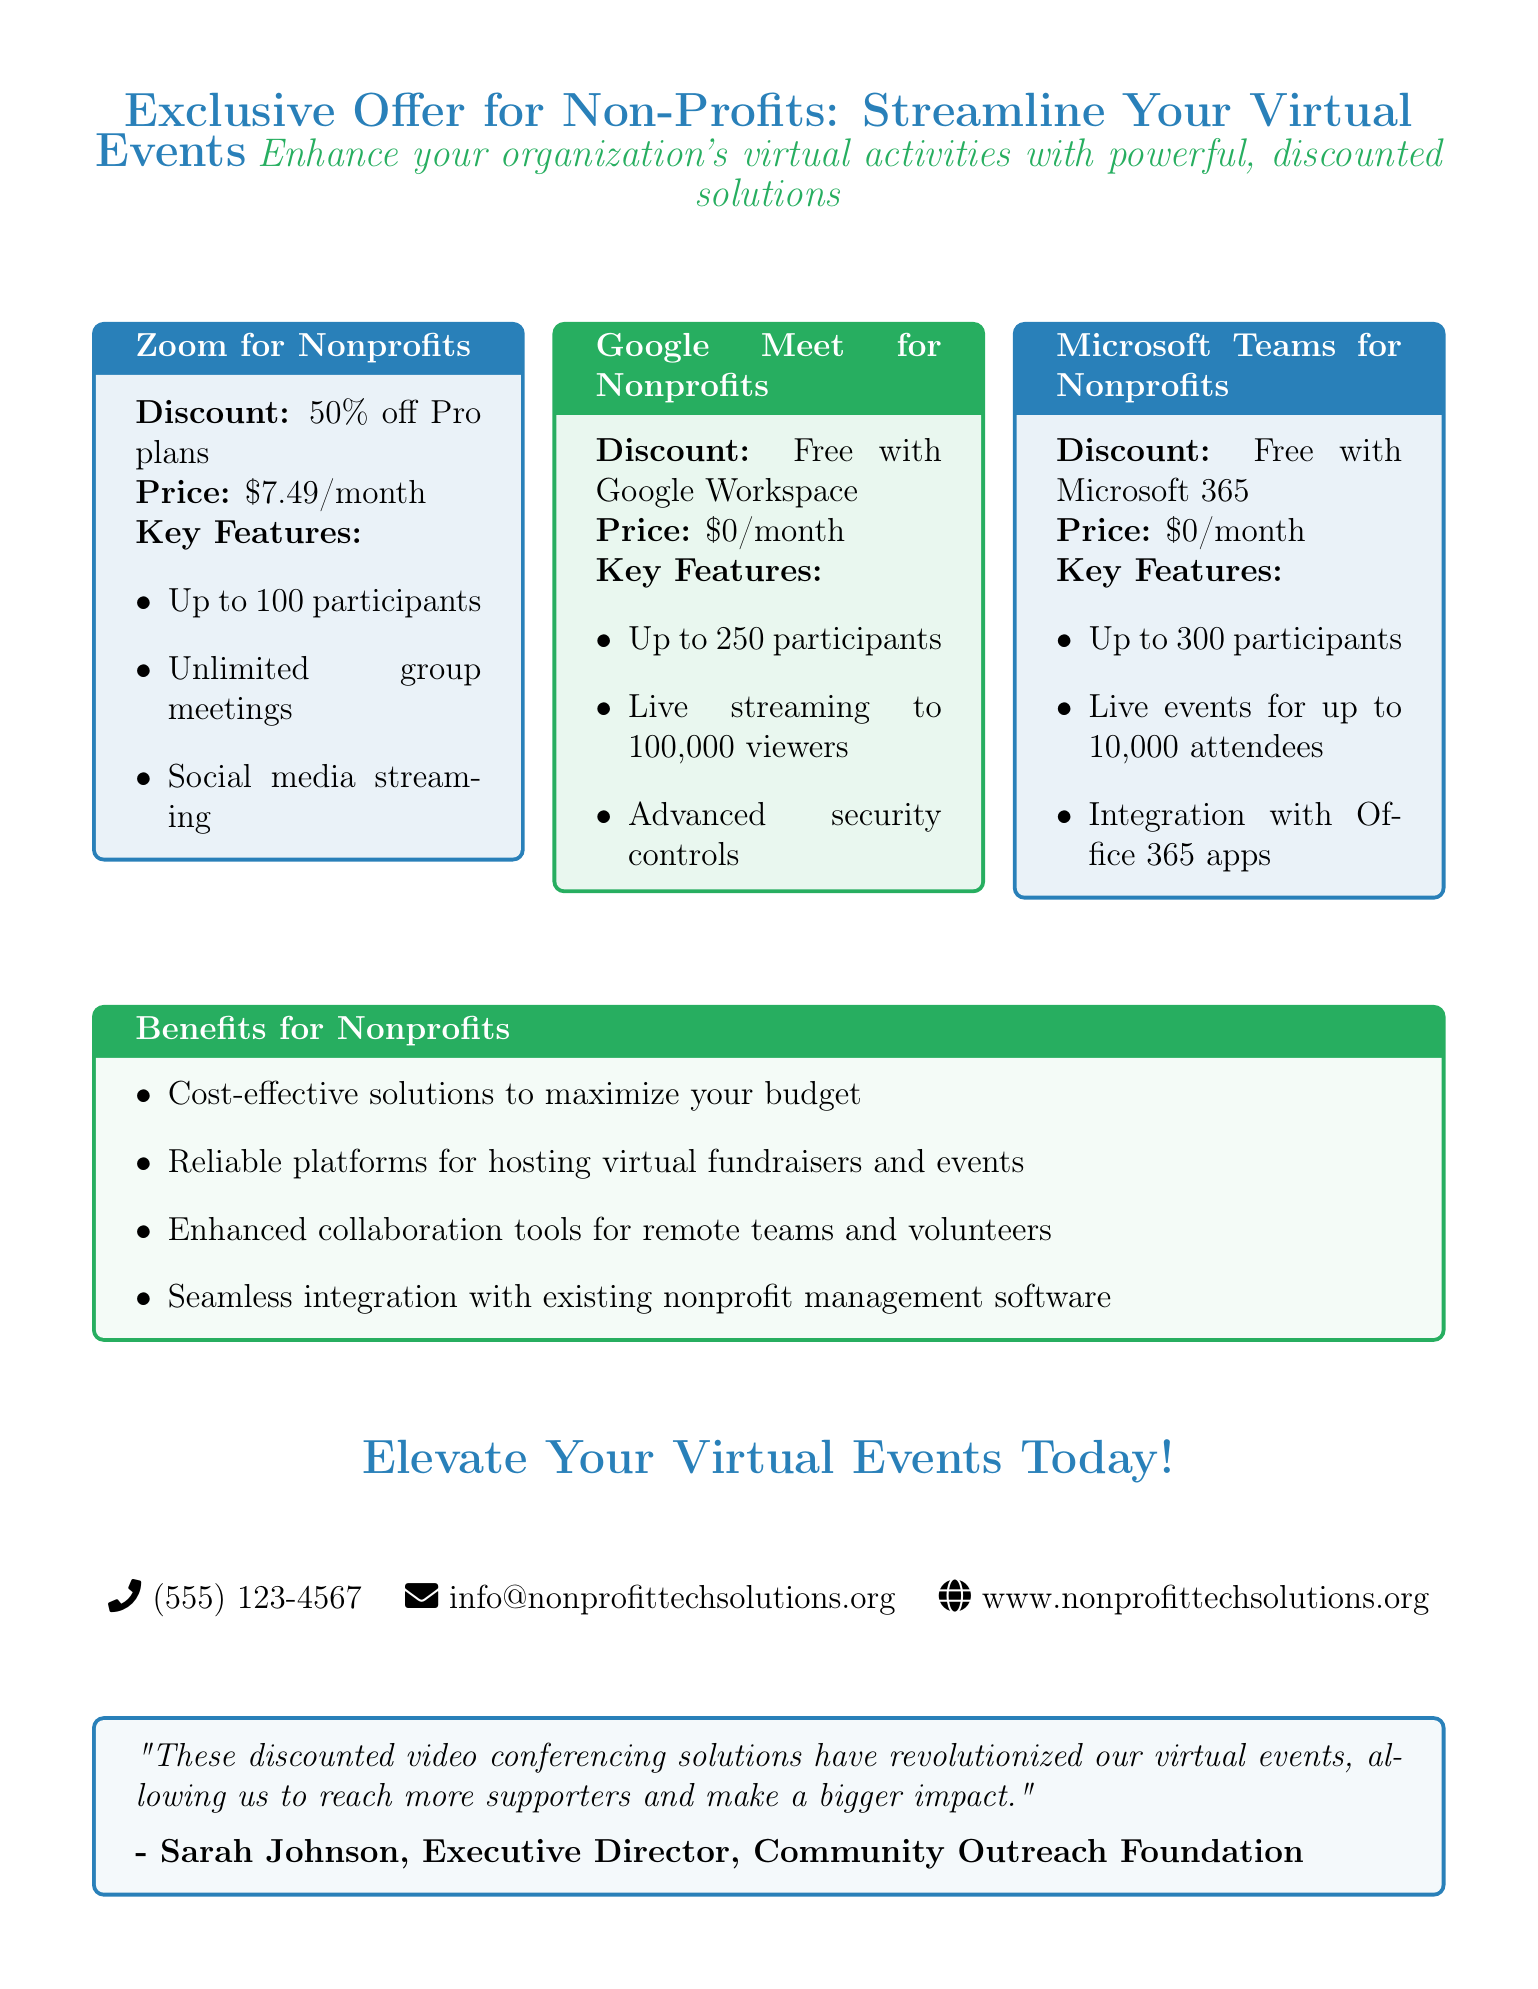What discount is offered for Zoom for Nonprofits? The discount mentioned for Zoom for Nonprofits is 50% off Pro plans.
Answer: 50% off Pro plans How many participants can join Microsoft Teams for Nonprofits? Microsoft Teams for Nonprofits allows up to 300 participants.
Answer: 300 participants What is the monthly price for Google Meet for Nonprofits? The document states that Google Meet for Nonprofits has a price of $0 per month.
Answer: $0 What is one key feature of the Google Meet for Nonprofits software? One key feature of Google Meet for Nonprofits is live streaming to 100,000 viewers.
Answer: Live streaming to 100,000 viewers What is a benefit for non-profits mentioned in the document? The document lists "Reliable platforms for hosting virtual fundraisers and events" as a benefit for non-profits.
Answer: Reliable platforms for hosting virtual fundraisers and events Who provided a testimonial about the video conferencing solutions? The testimonial was provided by Sarah Johnson, Executive Director of the Community Outreach Foundation.
Answer: Sarah Johnson, Executive Director, Community Outreach Foundation What is the monthly price for Zoom for Nonprofits? The price for Zoom for Nonprofits is stated as $7.49 per month.
Answer: $7.49 What feature is included in Microsoft Teams for Nonprofits related to event attendance? Microsoft Teams for Nonprofits includes live events for up to 10,000 attendees.
Answer: Live events for up to 10,000 attendees 